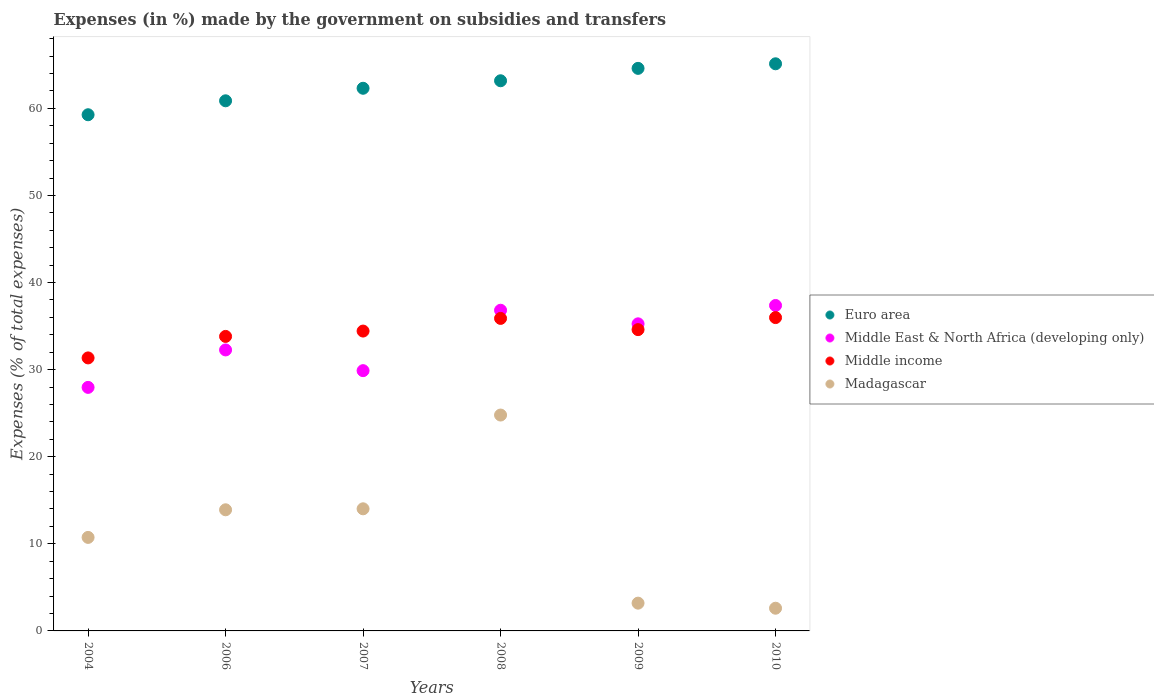Is the number of dotlines equal to the number of legend labels?
Give a very brief answer. Yes. What is the percentage of expenses made by the government on subsidies and transfers in Middle income in 2006?
Keep it short and to the point. 33.82. Across all years, what is the maximum percentage of expenses made by the government on subsidies and transfers in Madagascar?
Keep it short and to the point. 24.79. Across all years, what is the minimum percentage of expenses made by the government on subsidies and transfers in Euro area?
Provide a succinct answer. 59.27. What is the total percentage of expenses made by the government on subsidies and transfers in Madagascar in the graph?
Offer a terse response. 69.25. What is the difference between the percentage of expenses made by the government on subsidies and transfers in Middle income in 2006 and that in 2010?
Ensure brevity in your answer.  -2.16. What is the difference between the percentage of expenses made by the government on subsidies and transfers in Euro area in 2006 and the percentage of expenses made by the government on subsidies and transfers in Madagascar in 2004?
Offer a very short reply. 50.13. What is the average percentage of expenses made by the government on subsidies and transfers in Madagascar per year?
Keep it short and to the point. 11.54. In the year 2007, what is the difference between the percentage of expenses made by the government on subsidies and transfers in Middle income and percentage of expenses made by the government on subsidies and transfers in Madagascar?
Your answer should be compact. 20.41. What is the ratio of the percentage of expenses made by the government on subsidies and transfers in Madagascar in 2004 to that in 2007?
Provide a short and direct response. 0.77. What is the difference between the highest and the second highest percentage of expenses made by the government on subsidies and transfers in Middle East & North Africa (developing only)?
Give a very brief answer. 0.55. What is the difference between the highest and the lowest percentage of expenses made by the government on subsidies and transfers in Madagascar?
Your response must be concise. 22.18. Is the sum of the percentage of expenses made by the government on subsidies and transfers in Middle income in 2006 and 2007 greater than the maximum percentage of expenses made by the government on subsidies and transfers in Madagascar across all years?
Ensure brevity in your answer.  Yes. Is it the case that in every year, the sum of the percentage of expenses made by the government on subsidies and transfers in Middle East & North Africa (developing only) and percentage of expenses made by the government on subsidies and transfers in Madagascar  is greater than the percentage of expenses made by the government on subsidies and transfers in Middle income?
Provide a succinct answer. Yes. Does the percentage of expenses made by the government on subsidies and transfers in Middle income monotonically increase over the years?
Your answer should be very brief. No. How many years are there in the graph?
Offer a very short reply. 6. Where does the legend appear in the graph?
Give a very brief answer. Center right. What is the title of the graph?
Provide a short and direct response. Expenses (in %) made by the government on subsidies and transfers. What is the label or title of the X-axis?
Your answer should be compact. Years. What is the label or title of the Y-axis?
Provide a succinct answer. Expenses (% of total expenses). What is the Expenses (% of total expenses) in Euro area in 2004?
Offer a very short reply. 59.27. What is the Expenses (% of total expenses) in Middle East & North Africa (developing only) in 2004?
Provide a succinct answer. 27.96. What is the Expenses (% of total expenses) of Middle income in 2004?
Offer a terse response. 31.35. What is the Expenses (% of total expenses) of Madagascar in 2004?
Provide a short and direct response. 10.74. What is the Expenses (% of total expenses) of Euro area in 2006?
Make the answer very short. 60.87. What is the Expenses (% of total expenses) of Middle East & North Africa (developing only) in 2006?
Make the answer very short. 32.26. What is the Expenses (% of total expenses) of Middle income in 2006?
Ensure brevity in your answer.  33.82. What is the Expenses (% of total expenses) of Madagascar in 2006?
Keep it short and to the point. 13.91. What is the Expenses (% of total expenses) of Euro area in 2007?
Make the answer very short. 62.31. What is the Expenses (% of total expenses) in Middle East & North Africa (developing only) in 2007?
Give a very brief answer. 29.88. What is the Expenses (% of total expenses) in Middle income in 2007?
Make the answer very short. 34.43. What is the Expenses (% of total expenses) in Madagascar in 2007?
Keep it short and to the point. 14.02. What is the Expenses (% of total expenses) of Euro area in 2008?
Make the answer very short. 63.17. What is the Expenses (% of total expenses) of Middle East & North Africa (developing only) in 2008?
Make the answer very short. 36.82. What is the Expenses (% of total expenses) in Middle income in 2008?
Offer a terse response. 35.88. What is the Expenses (% of total expenses) of Madagascar in 2008?
Your answer should be very brief. 24.79. What is the Expenses (% of total expenses) in Euro area in 2009?
Make the answer very short. 64.59. What is the Expenses (% of total expenses) in Middle East & North Africa (developing only) in 2009?
Provide a short and direct response. 35.26. What is the Expenses (% of total expenses) in Middle income in 2009?
Your answer should be very brief. 34.59. What is the Expenses (% of total expenses) in Madagascar in 2009?
Keep it short and to the point. 3.19. What is the Expenses (% of total expenses) of Euro area in 2010?
Ensure brevity in your answer.  65.12. What is the Expenses (% of total expenses) in Middle East & North Africa (developing only) in 2010?
Your answer should be very brief. 37.37. What is the Expenses (% of total expenses) of Middle income in 2010?
Give a very brief answer. 35.98. What is the Expenses (% of total expenses) of Madagascar in 2010?
Offer a terse response. 2.61. Across all years, what is the maximum Expenses (% of total expenses) in Euro area?
Offer a terse response. 65.12. Across all years, what is the maximum Expenses (% of total expenses) of Middle East & North Africa (developing only)?
Provide a short and direct response. 37.37. Across all years, what is the maximum Expenses (% of total expenses) of Middle income?
Your response must be concise. 35.98. Across all years, what is the maximum Expenses (% of total expenses) of Madagascar?
Your answer should be very brief. 24.79. Across all years, what is the minimum Expenses (% of total expenses) of Euro area?
Ensure brevity in your answer.  59.27. Across all years, what is the minimum Expenses (% of total expenses) in Middle East & North Africa (developing only)?
Provide a short and direct response. 27.96. Across all years, what is the minimum Expenses (% of total expenses) of Middle income?
Keep it short and to the point. 31.35. Across all years, what is the minimum Expenses (% of total expenses) of Madagascar?
Keep it short and to the point. 2.61. What is the total Expenses (% of total expenses) in Euro area in the graph?
Ensure brevity in your answer.  375.33. What is the total Expenses (% of total expenses) in Middle East & North Africa (developing only) in the graph?
Ensure brevity in your answer.  199.56. What is the total Expenses (% of total expenses) of Middle income in the graph?
Ensure brevity in your answer.  206.05. What is the total Expenses (% of total expenses) of Madagascar in the graph?
Provide a succinct answer. 69.25. What is the difference between the Expenses (% of total expenses) of Euro area in 2004 and that in 2006?
Offer a terse response. -1.6. What is the difference between the Expenses (% of total expenses) in Middle East & North Africa (developing only) in 2004 and that in 2006?
Ensure brevity in your answer.  -4.3. What is the difference between the Expenses (% of total expenses) in Middle income in 2004 and that in 2006?
Offer a terse response. -2.47. What is the difference between the Expenses (% of total expenses) of Madagascar in 2004 and that in 2006?
Ensure brevity in your answer.  -3.17. What is the difference between the Expenses (% of total expenses) in Euro area in 2004 and that in 2007?
Your response must be concise. -3.04. What is the difference between the Expenses (% of total expenses) of Middle East & North Africa (developing only) in 2004 and that in 2007?
Provide a short and direct response. -1.92. What is the difference between the Expenses (% of total expenses) in Middle income in 2004 and that in 2007?
Your response must be concise. -3.08. What is the difference between the Expenses (% of total expenses) of Madagascar in 2004 and that in 2007?
Make the answer very short. -3.28. What is the difference between the Expenses (% of total expenses) in Euro area in 2004 and that in 2008?
Provide a short and direct response. -3.9. What is the difference between the Expenses (% of total expenses) of Middle East & North Africa (developing only) in 2004 and that in 2008?
Your answer should be compact. -8.86. What is the difference between the Expenses (% of total expenses) in Middle income in 2004 and that in 2008?
Provide a short and direct response. -4.54. What is the difference between the Expenses (% of total expenses) in Madagascar in 2004 and that in 2008?
Offer a very short reply. -14.05. What is the difference between the Expenses (% of total expenses) of Euro area in 2004 and that in 2009?
Provide a short and direct response. -5.33. What is the difference between the Expenses (% of total expenses) in Middle East & North Africa (developing only) in 2004 and that in 2009?
Your response must be concise. -7.3. What is the difference between the Expenses (% of total expenses) in Middle income in 2004 and that in 2009?
Offer a very short reply. -3.25. What is the difference between the Expenses (% of total expenses) of Madagascar in 2004 and that in 2009?
Offer a terse response. 7.55. What is the difference between the Expenses (% of total expenses) in Euro area in 2004 and that in 2010?
Your answer should be very brief. -5.85. What is the difference between the Expenses (% of total expenses) of Middle East & North Africa (developing only) in 2004 and that in 2010?
Offer a terse response. -9.4. What is the difference between the Expenses (% of total expenses) in Middle income in 2004 and that in 2010?
Ensure brevity in your answer.  -4.63. What is the difference between the Expenses (% of total expenses) in Madagascar in 2004 and that in 2010?
Your answer should be very brief. 8.13. What is the difference between the Expenses (% of total expenses) of Euro area in 2006 and that in 2007?
Provide a short and direct response. -1.44. What is the difference between the Expenses (% of total expenses) of Middle East & North Africa (developing only) in 2006 and that in 2007?
Make the answer very short. 2.38. What is the difference between the Expenses (% of total expenses) of Middle income in 2006 and that in 2007?
Provide a short and direct response. -0.61. What is the difference between the Expenses (% of total expenses) in Madagascar in 2006 and that in 2007?
Your response must be concise. -0.11. What is the difference between the Expenses (% of total expenses) in Euro area in 2006 and that in 2008?
Offer a terse response. -2.3. What is the difference between the Expenses (% of total expenses) in Middle East & North Africa (developing only) in 2006 and that in 2008?
Your response must be concise. -4.56. What is the difference between the Expenses (% of total expenses) of Middle income in 2006 and that in 2008?
Provide a succinct answer. -2.07. What is the difference between the Expenses (% of total expenses) in Madagascar in 2006 and that in 2008?
Your answer should be very brief. -10.88. What is the difference between the Expenses (% of total expenses) of Euro area in 2006 and that in 2009?
Ensure brevity in your answer.  -3.72. What is the difference between the Expenses (% of total expenses) in Middle East & North Africa (developing only) in 2006 and that in 2009?
Offer a very short reply. -3. What is the difference between the Expenses (% of total expenses) in Middle income in 2006 and that in 2009?
Give a very brief answer. -0.78. What is the difference between the Expenses (% of total expenses) in Madagascar in 2006 and that in 2009?
Provide a succinct answer. 10.72. What is the difference between the Expenses (% of total expenses) in Euro area in 2006 and that in 2010?
Ensure brevity in your answer.  -4.25. What is the difference between the Expenses (% of total expenses) in Middle East & North Africa (developing only) in 2006 and that in 2010?
Your answer should be very brief. -5.1. What is the difference between the Expenses (% of total expenses) in Middle income in 2006 and that in 2010?
Provide a short and direct response. -2.16. What is the difference between the Expenses (% of total expenses) of Madagascar in 2006 and that in 2010?
Make the answer very short. 11.3. What is the difference between the Expenses (% of total expenses) in Euro area in 2007 and that in 2008?
Provide a succinct answer. -0.86. What is the difference between the Expenses (% of total expenses) in Middle East & North Africa (developing only) in 2007 and that in 2008?
Your response must be concise. -6.94. What is the difference between the Expenses (% of total expenses) of Middle income in 2007 and that in 2008?
Offer a very short reply. -1.45. What is the difference between the Expenses (% of total expenses) of Madagascar in 2007 and that in 2008?
Offer a very short reply. -10.77. What is the difference between the Expenses (% of total expenses) in Euro area in 2007 and that in 2009?
Offer a very short reply. -2.29. What is the difference between the Expenses (% of total expenses) in Middle East & North Africa (developing only) in 2007 and that in 2009?
Your answer should be compact. -5.38. What is the difference between the Expenses (% of total expenses) of Middle income in 2007 and that in 2009?
Offer a terse response. -0.16. What is the difference between the Expenses (% of total expenses) in Madagascar in 2007 and that in 2009?
Offer a very short reply. 10.83. What is the difference between the Expenses (% of total expenses) in Euro area in 2007 and that in 2010?
Offer a terse response. -2.81. What is the difference between the Expenses (% of total expenses) of Middle East & North Africa (developing only) in 2007 and that in 2010?
Provide a succinct answer. -7.48. What is the difference between the Expenses (% of total expenses) in Middle income in 2007 and that in 2010?
Provide a succinct answer. -1.55. What is the difference between the Expenses (% of total expenses) of Madagascar in 2007 and that in 2010?
Your answer should be compact. 11.41. What is the difference between the Expenses (% of total expenses) in Euro area in 2008 and that in 2009?
Keep it short and to the point. -1.42. What is the difference between the Expenses (% of total expenses) of Middle East & North Africa (developing only) in 2008 and that in 2009?
Ensure brevity in your answer.  1.56. What is the difference between the Expenses (% of total expenses) of Middle income in 2008 and that in 2009?
Offer a very short reply. 1.29. What is the difference between the Expenses (% of total expenses) of Madagascar in 2008 and that in 2009?
Provide a succinct answer. 21.6. What is the difference between the Expenses (% of total expenses) in Euro area in 2008 and that in 2010?
Your response must be concise. -1.95. What is the difference between the Expenses (% of total expenses) in Middle East & North Africa (developing only) in 2008 and that in 2010?
Your answer should be very brief. -0.55. What is the difference between the Expenses (% of total expenses) of Middle income in 2008 and that in 2010?
Your response must be concise. -0.09. What is the difference between the Expenses (% of total expenses) of Madagascar in 2008 and that in 2010?
Provide a succinct answer. 22.18. What is the difference between the Expenses (% of total expenses) in Euro area in 2009 and that in 2010?
Offer a very short reply. -0.52. What is the difference between the Expenses (% of total expenses) in Middle East & North Africa (developing only) in 2009 and that in 2010?
Make the answer very short. -2.11. What is the difference between the Expenses (% of total expenses) in Middle income in 2009 and that in 2010?
Your answer should be compact. -1.38. What is the difference between the Expenses (% of total expenses) in Madagascar in 2009 and that in 2010?
Make the answer very short. 0.58. What is the difference between the Expenses (% of total expenses) of Euro area in 2004 and the Expenses (% of total expenses) of Middle East & North Africa (developing only) in 2006?
Ensure brevity in your answer.  27. What is the difference between the Expenses (% of total expenses) of Euro area in 2004 and the Expenses (% of total expenses) of Middle income in 2006?
Offer a very short reply. 25.45. What is the difference between the Expenses (% of total expenses) in Euro area in 2004 and the Expenses (% of total expenses) in Madagascar in 2006?
Keep it short and to the point. 45.36. What is the difference between the Expenses (% of total expenses) in Middle East & North Africa (developing only) in 2004 and the Expenses (% of total expenses) in Middle income in 2006?
Offer a very short reply. -5.85. What is the difference between the Expenses (% of total expenses) in Middle East & North Africa (developing only) in 2004 and the Expenses (% of total expenses) in Madagascar in 2006?
Your answer should be compact. 14.06. What is the difference between the Expenses (% of total expenses) in Middle income in 2004 and the Expenses (% of total expenses) in Madagascar in 2006?
Provide a short and direct response. 17.44. What is the difference between the Expenses (% of total expenses) in Euro area in 2004 and the Expenses (% of total expenses) in Middle East & North Africa (developing only) in 2007?
Provide a succinct answer. 29.38. What is the difference between the Expenses (% of total expenses) of Euro area in 2004 and the Expenses (% of total expenses) of Middle income in 2007?
Offer a terse response. 24.84. What is the difference between the Expenses (% of total expenses) of Euro area in 2004 and the Expenses (% of total expenses) of Madagascar in 2007?
Provide a succinct answer. 45.25. What is the difference between the Expenses (% of total expenses) of Middle East & North Africa (developing only) in 2004 and the Expenses (% of total expenses) of Middle income in 2007?
Offer a terse response. -6.47. What is the difference between the Expenses (% of total expenses) in Middle East & North Africa (developing only) in 2004 and the Expenses (% of total expenses) in Madagascar in 2007?
Make the answer very short. 13.94. What is the difference between the Expenses (% of total expenses) of Middle income in 2004 and the Expenses (% of total expenses) of Madagascar in 2007?
Provide a short and direct response. 17.33. What is the difference between the Expenses (% of total expenses) in Euro area in 2004 and the Expenses (% of total expenses) in Middle East & North Africa (developing only) in 2008?
Offer a terse response. 22.45. What is the difference between the Expenses (% of total expenses) in Euro area in 2004 and the Expenses (% of total expenses) in Middle income in 2008?
Offer a very short reply. 23.38. What is the difference between the Expenses (% of total expenses) of Euro area in 2004 and the Expenses (% of total expenses) of Madagascar in 2008?
Your answer should be very brief. 34.48. What is the difference between the Expenses (% of total expenses) of Middle East & North Africa (developing only) in 2004 and the Expenses (% of total expenses) of Middle income in 2008?
Your answer should be very brief. -7.92. What is the difference between the Expenses (% of total expenses) in Middle East & North Africa (developing only) in 2004 and the Expenses (% of total expenses) in Madagascar in 2008?
Keep it short and to the point. 3.18. What is the difference between the Expenses (% of total expenses) of Middle income in 2004 and the Expenses (% of total expenses) of Madagascar in 2008?
Your answer should be compact. 6.56. What is the difference between the Expenses (% of total expenses) of Euro area in 2004 and the Expenses (% of total expenses) of Middle East & North Africa (developing only) in 2009?
Offer a very short reply. 24.01. What is the difference between the Expenses (% of total expenses) of Euro area in 2004 and the Expenses (% of total expenses) of Middle income in 2009?
Provide a succinct answer. 24.67. What is the difference between the Expenses (% of total expenses) of Euro area in 2004 and the Expenses (% of total expenses) of Madagascar in 2009?
Offer a terse response. 56.08. What is the difference between the Expenses (% of total expenses) of Middle East & North Africa (developing only) in 2004 and the Expenses (% of total expenses) of Middle income in 2009?
Keep it short and to the point. -6.63. What is the difference between the Expenses (% of total expenses) of Middle East & North Africa (developing only) in 2004 and the Expenses (% of total expenses) of Madagascar in 2009?
Offer a very short reply. 24.77. What is the difference between the Expenses (% of total expenses) of Middle income in 2004 and the Expenses (% of total expenses) of Madagascar in 2009?
Your response must be concise. 28.16. What is the difference between the Expenses (% of total expenses) in Euro area in 2004 and the Expenses (% of total expenses) in Middle East & North Africa (developing only) in 2010?
Make the answer very short. 21.9. What is the difference between the Expenses (% of total expenses) of Euro area in 2004 and the Expenses (% of total expenses) of Middle income in 2010?
Keep it short and to the point. 23.29. What is the difference between the Expenses (% of total expenses) in Euro area in 2004 and the Expenses (% of total expenses) in Madagascar in 2010?
Your answer should be very brief. 56.66. What is the difference between the Expenses (% of total expenses) in Middle East & North Africa (developing only) in 2004 and the Expenses (% of total expenses) in Middle income in 2010?
Keep it short and to the point. -8.01. What is the difference between the Expenses (% of total expenses) of Middle East & North Africa (developing only) in 2004 and the Expenses (% of total expenses) of Madagascar in 2010?
Provide a short and direct response. 25.36. What is the difference between the Expenses (% of total expenses) in Middle income in 2004 and the Expenses (% of total expenses) in Madagascar in 2010?
Provide a succinct answer. 28.74. What is the difference between the Expenses (% of total expenses) of Euro area in 2006 and the Expenses (% of total expenses) of Middle East & North Africa (developing only) in 2007?
Your response must be concise. 30.99. What is the difference between the Expenses (% of total expenses) in Euro area in 2006 and the Expenses (% of total expenses) in Middle income in 2007?
Provide a short and direct response. 26.44. What is the difference between the Expenses (% of total expenses) in Euro area in 2006 and the Expenses (% of total expenses) in Madagascar in 2007?
Provide a short and direct response. 46.85. What is the difference between the Expenses (% of total expenses) of Middle East & North Africa (developing only) in 2006 and the Expenses (% of total expenses) of Middle income in 2007?
Offer a very short reply. -2.17. What is the difference between the Expenses (% of total expenses) of Middle East & North Africa (developing only) in 2006 and the Expenses (% of total expenses) of Madagascar in 2007?
Your answer should be very brief. 18.24. What is the difference between the Expenses (% of total expenses) in Middle income in 2006 and the Expenses (% of total expenses) in Madagascar in 2007?
Keep it short and to the point. 19.79. What is the difference between the Expenses (% of total expenses) in Euro area in 2006 and the Expenses (% of total expenses) in Middle East & North Africa (developing only) in 2008?
Make the answer very short. 24.05. What is the difference between the Expenses (% of total expenses) in Euro area in 2006 and the Expenses (% of total expenses) in Middle income in 2008?
Provide a short and direct response. 24.99. What is the difference between the Expenses (% of total expenses) of Euro area in 2006 and the Expenses (% of total expenses) of Madagascar in 2008?
Offer a terse response. 36.08. What is the difference between the Expenses (% of total expenses) of Middle East & North Africa (developing only) in 2006 and the Expenses (% of total expenses) of Middle income in 2008?
Offer a very short reply. -3.62. What is the difference between the Expenses (% of total expenses) in Middle East & North Africa (developing only) in 2006 and the Expenses (% of total expenses) in Madagascar in 2008?
Make the answer very short. 7.48. What is the difference between the Expenses (% of total expenses) in Middle income in 2006 and the Expenses (% of total expenses) in Madagascar in 2008?
Provide a short and direct response. 9.03. What is the difference between the Expenses (% of total expenses) of Euro area in 2006 and the Expenses (% of total expenses) of Middle East & North Africa (developing only) in 2009?
Give a very brief answer. 25.61. What is the difference between the Expenses (% of total expenses) of Euro area in 2006 and the Expenses (% of total expenses) of Middle income in 2009?
Provide a succinct answer. 26.28. What is the difference between the Expenses (% of total expenses) of Euro area in 2006 and the Expenses (% of total expenses) of Madagascar in 2009?
Your response must be concise. 57.68. What is the difference between the Expenses (% of total expenses) of Middle East & North Africa (developing only) in 2006 and the Expenses (% of total expenses) of Middle income in 2009?
Offer a terse response. -2.33. What is the difference between the Expenses (% of total expenses) of Middle East & North Africa (developing only) in 2006 and the Expenses (% of total expenses) of Madagascar in 2009?
Keep it short and to the point. 29.08. What is the difference between the Expenses (% of total expenses) of Middle income in 2006 and the Expenses (% of total expenses) of Madagascar in 2009?
Offer a very short reply. 30.63. What is the difference between the Expenses (% of total expenses) of Euro area in 2006 and the Expenses (% of total expenses) of Middle East & North Africa (developing only) in 2010?
Provide a short and direct response. 23.5. What is the difference between the Expenses (% of total expenses) of Euro area in 2006 and the Expenses (% of total expenses) of Middle income in 2010?
Offer a very short reply. 24.89. What is the difference between the Expenses (% of total expenses) of Euro area in 2006 and the Expenses (% of total expenses) of Madagascar in 2010?
Keep it short and to the point. 58.26. What is the difference between the Expenses (% of total expenses) in Middle East & North Africa (developing only) in 2006 and the Expenses (% of total expenses) in Middle income in 2010?
Provide a short and direct response. -3.71. What is the difference between the Expenses (% of total expenses) of Middle East & North Africa (developing only) in 2006 and the Expenses (% of total expenses) of Madagascar in 2010?
Make the answer very short. 29.66. What is the difference between the Expenses (% of total expenses) in Middle income in 2006 and the Expenses (% of total expenses) in Madagascar in 2010?
Keep it short and to the point. 31.21. What is the difference between the Expenses (% of total expenses) of Euro area in 2007 and the Expenses (% of total expenses) of Middle East & North Africa (developing only) in 2008?
Keep it short and to the point. 25.49. What is the difference between the Expenses (% of total expenses) of Euro area in 2007 and the Expenses (% of total expenses) of Middle income in 2008?
Provide a succinct answer. 26.42. What is the difference between the Expenses (% of total expenses) in Euro area in 2007 and the Expenses (% of total expenses) in Madagascar in 2008?
Provide a short and direct response. 37.52. What is the difference between the Expenses (% of total expenses) of Middle East & North Africa (developing only) in 2007 and the Expenses (% of total expenses) of Middle income in 2008?
Offer a terse response. -6. What is the difference between the Expenses (% of total expenses) in Middle East & North Africa (developing only) in 2007 and the Expenses (% of total expenses) in Madagascar in 2008?
Offer a very short reply. 5.1. What is the difference between the Expenses (% of total expenses) in Middle income in 2007 and the Expenses (% of total expenses) in Madagascar in 2008?
Your response must be concise. 9.64. What is the difference between the Expenses (% of total expenses) in Euro area in 2007 and the Expenses (% of total expenses) in Middle East & North Africa (developing only) in 2009?
Ensure brevity in your answer.  27.05. What is the difference between the Expenses (% of total expenses) in Euro area in 2007 and the Expenses (% of total expenses) in Middle income in 2009?
Provide a succinct answer. 27.71. What is the difference between the Expenses (% of total expenses) of Euro area in 2007 and the Expenses (% of total expenses) of Madagascar in 2009?
Your response must be concise. 59.12. What is the difference between the Expenses (% of total expenses) in Middle East & North Africa (developing only) in 2007 and the Expenses (% of total expenses) in Middle income in 2009?
Offer a very short reply. -4.71. What is the difference between the Expenses (% of total expenses) of Middle East & North Africa (developing only) in 2007 and the Expenses (% of total expenses) of Madagascar in 2009?
Give a very brief answer. 26.7. What is the difference between the Expenses (% of total expenses) of Middle income in 2007 and the Expenses (% of total expenses) of Madagascar in 2009?
Offer a very short reply. 31.24. What is the difference between the Expenses (% of total expenses) in Euro area in 2007 and the Expenses (% of total expenses) in Middle East & North Africa (developing only) in 2010?
Provide a short and direct response. 24.94. What is the difference between the Expenses (% of total expenses) in Euro area in 2007 and the Expenses (% of total expenses) in Middle income in 2010?
Provide a succinct answer. 26.33. What is the difference between the Expenses (% of total expenses) in Euro area in 2007 and the Expenses (% of total expenses) in Madagascar in 2010?
Your response must be concise. 59.7. What is the difference between the Expenses (% of total expenses) in Middle East & North Africa (developing only) in 2007 and the Expenses (% of total expenses) in Middle income in 2010?
Ensure brevity in your answer.  -6.09. What is the difference between the Expenses (% of total expenses) in Middle East & North Africa (developing only) in 2007 and the Expenses (% of total expenses) in Madagascar in 2010?
Keep it short and to the point. 27.28. What is the difference between the Expenses (% of total expenses) in Middle income in 2007 and the Expenses (% of total expenses) in Madagascar in 2010?
Offer a terse response. 31.82. What is the difference between the Expenses (% of total expenses) of Euro area in 2008 and the Expenses (% of total expenses) of Middle East & North Africa (developing only) in 2009?
Your response must be concise. 27.91. What is the difference between the Expenses (% of total expenses) of Euro area in 2008 and the Expenses (% of total expenses) of Middle income in 2009?
Provide a succinct answer. 28.58. What is the difference between the Expenses (% of total expenses) of Euro area in 2008 and the Expenses (% of total expenses) of Madagascar in 2009?
Give a very brief answer. 59.98. What is the difference between the Expenses (% of total expenses) in Middle East & North Africa (developing only) in 2008 and the Expenses (% of total expenses) in Middle income in 2009?
Offer a terse response. 2.23. What is the difference between the Expenses (% of total expenses) in Middle East & North Africa (developing only) in 2008 and the Expenses (% of total expenses) in Madagascar in 2009?
Make the answer very short. 33.63. What is the difference between the Expenses (% of total expenses) in Middle income in 2008 and the Expenses (% of total expenses) in Madagascar in 2009?
Keep it short and to the point. 32.69. What is the difference between the Expenses (% of total expenses) in Euro area in 2008 and the Expenses (% of total expenses) in Middle East & North Africa (developing only) in 2010?
Provide a succinct answer. 25.8. What is the difference between the Expenses (% of total expenses) in Euro area in 2008 and the Expenses (% of total expenses) in Middle income in 2010?
Your answer should be compact. 27.19. What is the difference between the Expenses (% of total expenses) of Euro area in 2008 and the Expenses (% of total expenses) of Madagascar in 2010?
Provide a succinct answer. 60.56. What is the difference between the Expenses (% of total expenses) in Middle East & North Africa (developing only) in 2008 and the Expenses (% of total expenses) in Middle income in 2010?
Ensure brevity in your answer.  0.84. What is the difference between the Expenses (% of total expenses) of Middle East & North Africa (developing only) in 2008 and the Expenses (% of total expenses) of Madagascar in 2010?
Your answer should be very brief. 34.21. What is the difference between the Expenses (% of total expenses) in Middle income in 2008 and the Expenses (% of total expenses) in Madagascar in 2010?
Offer a terse response. 33.28. What is the difference between the Expenses (% of total expenses) of Euro area in 2009 and the Expenses (% of total expenses) of Middle East & North Africa (developing only) in 2010?
Provide a short and direct response. 27.23. What is the difference between the Expenses (% of total expenses) in Euro area in 2009 and the Expenses (% of total expenses) in Middle income in 2010?
Your response must be concise. 28.62. What is the difference between the Expenses (% of total expenses) in Euro area in 2009 and the Expenses (% of total expenses) in Madagascar in 2010?
Offer a very short reply. 61.99. What is the difference between the Expenses (% of total expenses) of Middle East & North Africa (developing only) in 2009 and the Expenses (% of total expenses) of Middle income in 2010?
Your answer should be compact. -0.72. What is the difference between the Expenses (% of total expenses) in Middle East & North Africa (developing only) in 2009 and the Expenses (% of total expenses) in Madagascar in 2010?
Your response must be concise. 32.65. What is the difference between the Expenses (% of total expenses) of Middle income in 2009 and the Expenses (% of total expenses) of Madagascar in 2010?
Make the answer very short. 31.99. What is the average Expenses (% of total expenses) in Euro area per year?
Your answer should be very brief. 62.55. What is the average Expenses (% of total expenses) in Middle East & North Africa (developing only) per year?
Offer a terse response. 33.26. What is the average Expenses (% of total expenses) of Middle income per year?
Give a very brief answer. 34.34. What is the average Expenses (% of total expenses) of Madagascar per year?
Offer a very short reply. 11.54. In the year 2004, what is the difference between the Expenses (% of total expenses) of Euro area and Expenses (% of total expenses) of Middle East & North Africa (developing only)?
Keep it short and to the point. 31.3. In the year 2004, what is the difference between the Expenses (% of total expenses) in Euro area and Expenses (% of total expenses) in Middle income?
Ensure brevity in your answer.  27.92. In the year 2004, what is the difference between the Expenses (% of total expenses) of Euro area and Expenses (% of total expenses) of Madagascar?
Offer a terse response. 48.53. In the year 2004, what is the difference between the Expenses (% of total expenses) in Middle East & North Africa (developing only) and Expenses (% of total expenses) in Middle income?
Offer a very short reply. -3.38. In the year 2004, what is the difference between the Expenses (% of total expenses) in Middle East & North Africa (developing only) and Expenses (% of total expenses) in Madagascar?
Provide a succinct answer. 17.23. In the year 2004, what is the difference between the Expenses (% of total expenses) of Middle income and Expenses (% of total expenses) of Madagascar?
Give a very brief answer. 20.61. In the year 2006, what is the difference between the Expenses (% of total expenses) in Euro area and Expenses (% of total expenses) in Middle East & North Africa (developing only)?
Provide a short and direct response. 28.61. In the year 2006, what is the difference between the Expenses (% of total expenses) in Euro area and Expenses (% of total expenses) in Middle income?
Offer a terse response. 27.05. In the year 2006, what is the difference between the Expenses (% of total expenses) of Euro area and Expenses (% of total expenses) of Madagascar?
Offer a terse response. 46.96. In the year 2006, what is the difference between the Expenses (% of total expenses) of Middle East & North Africa (developing only) and Expenses (% of total expenses) of Middle income?
Your response must be concise. -1.55. In the year 2006, what is the difference between the Expenses (% of total expenses) in Middle East & North Africa (developing only) and Expenses (% of total expenses) in Madagascar?
Provide a succinct answer. 18.36. In the year 2006, what is the difference between the Expenses (% of total expenses) of Middle income and Expenses (% of total expenses) of Madagascar?
Your answer should be compact. 19.91. In the year 2007, what is the difference between the Expenses (% of total expenses) of Euro area and Expenses (% of total expenses) of Middle East & North Africa (developing only)?
Make the answer very short. 32.42. In the year 2007, what is the difference between the Expenses (% of total expenses) of Euro area and Expenses (% of total expenses) of Middle income?
Offer a terse response. 27.88. In the year 2007, what is the difference between the Expenses (% of total expenses) of Euro area and Expenses (% of total expenses) of Madagascar?
Make the answer very short. 48.29. In the year 2007, what is the difference between the Expenses (% of total expenses) in Middle East & North Africa (developing only) and Expenses (% of total expenses) in Middle income?
Your answer should be very brief. -4.55. In the year 2007, what is the difference between the Expenses (% of total expenses) in Middle East & North Africa (developing only) and Expenses (% of total expenses) in Madagascar?
Your answer should be compact. 15.86. In the year 2007, what is the difference between the Expenses (% of total expenses) of Middle income and Expenses (% of total expenses) of Madagascar?
Your response must be concise. 20.41. In the year 2008, what is the difference between the Expenses (% of total expenses) of Euro area and Expenses (% of total expenses) of Middle East & North Africa (developing only)?
Your answer should be compact. 26.35. In the year 2008, what is the difference between the Expenses (% of total expenses) in Euro area and Expenses (% of total expenses) in Middle income?
Give a very brief answer. 27.29. In the year 2008, what is the difference between the Expenses (% of total expenses) of Euro area and Expenses (% of total expenses) of Madagascar?
Give a very brief answer. 38.38. In the year 2008, what is the difference between the Expenses (% of total expenses) in Middle East & North Africa (developing only) and Expenses (% of total expenses) in Middle income?
Your answer should be compact. 0.94. In the year 2008, what is the difference between the Expenses (% of total expenses) of Middle East & North Africa (developing only) and Expenses (% of total expenses) of Madagascar?
Offer a terse response. 12.03. In the year 2008, what is the difference between the Expenses (% of total expenses) of Middle income and Expenses (% of total expenses) of Madagascar?
Provide a succinct answer. 11.1. In the year 2009, what is the difference between the Expenses (% of total expenses) of Euro area and Expenses (% of total expenses) of Middle East & North Africa (developing only)?
Make the answer very short. 29.33. In the year 2009, what is the difference between the Expenses (% of total expenses) in Euro area and Expenses (% of total expenses) in Middle income?
Offer a very short reply. 30. In the year 2009, what is the difference between the Expenses (% of total expenses) in Euro area and Expenses (% of total expenses) in Madagascar?
Provide a succinct answer. 61.4. In the year 2009, what is the difference between the Expenses (% of total expenses) in Middle East & North Africa (developing only) and Expenses (% of total expenses) in Middle income?
Your answer should be very brief. 0.67. In the year 2009, what is the difference between the Expenses (% of total expenses) of Middle East & North Africa (developing only) and Expenses (% of total expenses) of Madagascar?
Offer a terse response. 32.07. In the year 2009, what is the difference between the Expenses (% of total expenses) in Middle income and Expenses (% of total expenses) in Madagascar?
Offer a terse response. 31.41. In the year 2010, what is the difference between the Expenses (% of total expenses) in Euro area and Expenses (% of total expenses) in Middle East & North Africa (developing only)?
Provide a short and direct response. 27.75. In the year 2010, what is the difference between the Expenses (% of total expenses) of Euro area and Expenses (% of total expenses) of Middle income?
Offer a terse response. 29.14. In the year 2010, what is the difference between the Expenses (% of total expenses) of Euro area and Expenses (% of total expenses) of Madagascar?
Keep it short and to the point. 62.51. In the year 2010, what is the difference between the Expenses (% of total expenses) of Middle East & North Africa (developing only) and Expenses (% of total expenses) of Middle income?
Your answer should be very brief. 1.39. In the year 2010, what is the difference between the Expenses (% of total expenses) of Middle East & North Africa (developing only) and Expenses (% of total expenses) of Madagascar?
Offer a terse response. 34.76. In the year 2010, what is the difference between the Expenses (% of total expenses) of Middle income and Expenses (% of total expenses) of Madagascar?
Give a very brief answer. 33.37. What is the ratio of the Expenses (% of total expenses) of Euro area in 2004 to that in 2006?
Your answer should be very brief. 0.97. What is the ratio of the Expenses (% of total expenses) in Middle East & North Africa (developing only) in 2004 to that in 2006?
Your answer should be very brief. 0.87. What is the ratio of the Expenses (% of total expenses) of Middle income in 2004 to that in 2006?
Provide a succinct answer. 0.93. What is the ratio of the Expenses (% of total expenses) in Madagascar in 2004 to that in 2006?
Ensure brevity in your answer.  0.77. What is the ratio of the Expenses (% of total expenses) in Euro area in 2004 to that in 2007?
Your response must be concise. 0.95. What is the ratio of the Expenses (% of total expenses) of Middle East & North Africa (developing only) in 2004 to that in 2007?
Your answer should be very brief. 0.94. What is the ratio of the Expenses (% of total expenses) in Middle income in 2004 to that in 2007?
Make the answer very short. 0.91. What is the ratio of the Expenses (% of total expenses) in Madagascar in 2004 to that in 2007?
Give a very brief answer. 0.77. What is the ratio of the Expenses (% of total expenses) of Euro area in 2004 to that in 2008?
Ensure brevity in your answer.  0.94. What is the ratio of the Expenses (% of total expenses) in Middle East & North Africa (developing only) in 2004 to that in 2008?
Keep it short and to the point. 0.76. What is the ratio of the Expenses (% of total expenses) in Middle income in 2004 to that in 2008?
Keep it short and to the point. 0.87. What is the ratio of the Expenses (% of total expenses) in Madagascar in 2004 to that in 2008?
Offer a very short reply. 0.43. What is the ratio of the Expenses (% of total expenses) of Euro area in 2004 to that in 2009?
Provide a succinct answer. 0.92. What is the ratio of the Expenses (% of total expenses) of Middle East & North Africa (developing only) in 2004 to that in 2009?
Provide a succinct answer. 0.79. What is the ratio of the Expenses (% of total expenses) of Middle income in 2004 to that in 2009?
Provide a succinct answer. 0.91. What is the ratio of the Expenses (% of total expenses) in Madagascar in 2004 to that in 2009?
Offer a terse response. 3.37. What is the ratio of the Expenses (% of total expenses) in Euro area in 2004 to that in 2010?
Provide a short and direct response. 0.91. What is the ratio of the Expenses (% of total expenses) in Middle East & North Africa (developing only) in 2004 to that in 2010?
Make the answer very short. 0.75. What is the ratio of the Expenses (% of total expenses) in Middle income in 2004 to that in 2010?
Your response must be concise. 0.87. What is the ratio of the Expenses (% of total expenses) of Madagascar in 2004 to that in 2010?
Your answer should be compact. 4.12. What is the ratio of the Expenses (% of total expenses) in Euro area in 2006 to that in 2007?
Offer a terse response. 0.98. What is the ratio of the Expenses (% of total expenses) of Middle East & North Africa (developing only) in 2006 to that in 2007?
Provide a succinct answer. 1.08. What is the ratio of the Expenses (% of total expenses) of Middle income in 2006 to that in 2007?
Your response must be concise. 0.98. What is the ratio of the Expenses (% of total expenses) in Euro area in 2006 to that in 2008?
Keep it short and to the point. 0.96. What is the ratio of the Expenses (% of total expenses) of Middle East & North Africa (developing only) in 2006 to that in 2008?
Provide a succinct answer. 0.88. What is the ratio of the Expenses (% of total expenses) in Middle income in 2006 to that in 2008?
Keep it short and to the point. 0.94. What is the ratio of the Expenses (% of total expenses) of Madagascar in 2006 to that in 2008?
Keep it short and to the point. 0.56. What is the ratio of the Expenses (% of total expenses) of Euro area in 2006 to that in 2009?
Offer a terse response. 0.94. What is the ratio of the Expenses (% of total expenses) of Middle East & North Africa (developing only) in 2006 to that in 2009?
Your response must be concise. 0.92. What is the ratio of the Expenses (% of total expenses) in Middle income in 2006 to that in 2009?
Give a very brief answer. 0.98. What is the ratio of the Expenses (% of total expenses) of Madagascar in 2006 to that in 2009?
Provide a short and direct response. 4.36. What is the ratio of the Expenses (% of total expenses) in Euro area in 2006 to that in 2010?
Ensure brevity in your answer.  0.93. What is the ratio of the Expenses (% of total expenses) in Middle East & North Africa (developing only) in 2006 to that in 2010?
Offer a terse response. 0.86. What is the ratio of the Expenses (% of total expenses) in Middle income in 2006 to that in 2010?
Your response must be concise. 0.94. What is the ratio of the Expenses (% of total expenses) in Madagascar in 2006 to that in 2010?
Keep it short and to the point. 5.34. What is the ratio of the Expenses (% of total expenses) of Euro area in 2007 to that in 2008?
Your answer should be very brief. 0.99. What is the ratio of the Expenses (% of total expenses) of Middle East & North Africa (developing only) in 2007 to that in 2008?
Keep it short and to the point. 0.81. What is the ratio of the Expenses (% of total expenses) in Middle income in 2007 to that in 2008?
Keep it short and to the point. 0.96. What is the ratio of the Expenses (% of total expenses) in Madagascar in 2007 to that in 2008?
Keep it short and to the point. 0.57. What is the ratio of the Expenses (% of total expenses) of Euro area in 2007 to that in 2009?
Ensure brevity in your answer.  0.96. What is the ratio of the Expenses (% of total expenses) in Middle East & North Africa (developing only) in 2007 to that in 2009?
Make the answer very short. 0.85. What is the ratio of the Expenses (% of total expenses) of Madagascar in 2007 to that in 2009?
Make the answer very short. 4.4. What is the ratio of the Expenses (% of total expenses) of Euro area in 2007 to that in 2010?
Your answer should be compact. 0.96. What is the ratio of the Expenses (% of total expenses) in Middle East & North Africa (developing only) in 2007 to that in 2010?
Your answer should be very brief. 0.8. What is the ratio of the Expenses (% of total expenses) of Middle income in 2007 to that in 2010?
Give a very brief answer. 0.96. What is the ratio of the Expenses (% of total expenses) of Madagascar in 2007 to that in 2010?
Make the answer very short. 5.38. What is the ratio of the Expenses (% of total expenses) in Middle East & North Africa (developing only) in 2008 to that in 2009?
Offer a very short reply. 1.04. What is the ratio of the Expenses (% of total expenses) in Middle income in 2008 to that in 2009?
Offer a terse response. 1.04. What is the ratio of the Expenses (% of total expenses) of Madagascar in 2008 to that in 2009?
Your answer should be very brief. 7.77. What is the ratio of the Expenses (% of total expenses) of Euro area in 2008 to that in 2010?
Your response must be concise. 0.97. What is the ratio of the Expenses (% of total expenses) in Middle East & North Africa (developing only) in 2008 to that in 2010?
Ensure brevity in your answer.  0.99. What is the ratio of the Expenses (% of total expenses) of Madagascar in 2008 to that in 2010?
Your answer should be compact. 9.51. What is the ratio of the Expenses (% of total expenses) in Middle East & North Africa (developing only) in 2009 to that in 2010?
Your answer should be compact. 0.94. What is the ratio of the Expenses (% of total expenses) in Middle income in 2009 to that in 2010?
Your answer should be very brief. 0.96. What is the ratio of the Expenses (% of total expenses) of Madagascar in 2009 to that in 2010?
Your response must be concise. 1.22. What is the difference between the highest and the second highest Expenses (% of total expenses) of Euro area?
Your answer should be compact. 0.52. What is the difference between the highest and the second highest Expenses (% of total expenses) in Middle East & North Africa (developing only)?
Your answer should be very brief. 0.55. What is the difference between the highest and the second highest Expenses (% of total expenses) of Middle income?
Give a very brief answer. 0.09. What is the difference between the highest and the second highest Expenses (% of total expenses) of Madagascar?
Provide a succinct answer. 10.77. What is the difference between the highest and the lowest Expenses (% of total expenses) of Euro area?
Offer a very short reply. 5.85. What is the difference between the highest and the lowest Expenses (% of total expenses) of Middle East & North Africa (developing only)?
Your answer should be very brief. 9.4. What is the difference between the highest and the lowest Expenses (% of total expenses) in Middle income?
Ensure brevity in your answer.  4.63. What is the difference between the highest and the lowest Expenses (% of total expenses) of Madagascar?
Offer a terse response. 22.18. 